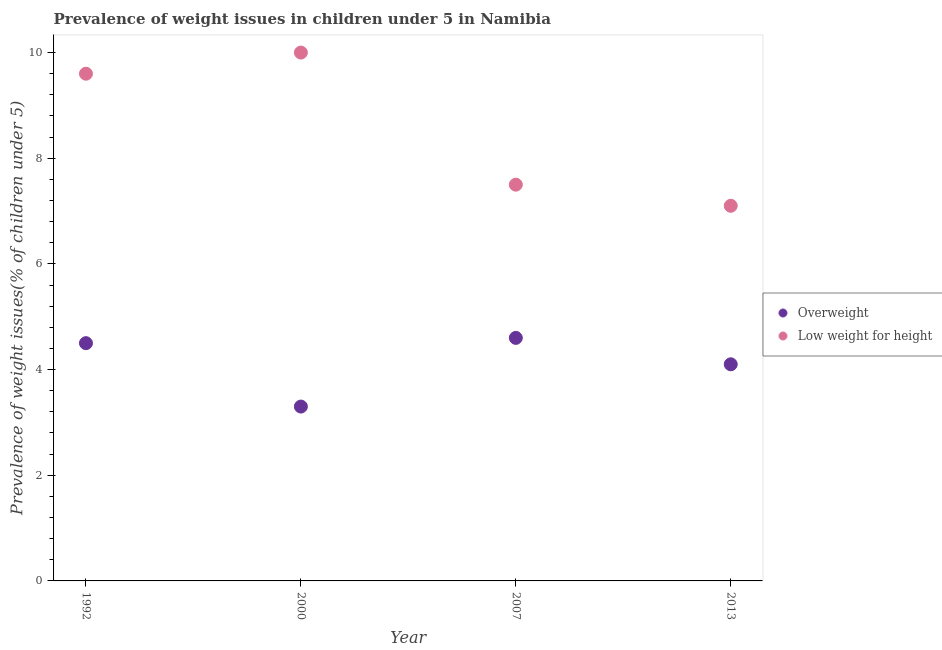How many different coloured dotlines are there?
Keep it short and to the point. 2. Is the number of dotlines equal to the number of legend labels?
Your answer should be very brief. Yes. What is the percentage of underweight children in 2007?
Your answer should be compact. 7.5. Across all years, what is the maximum percentage of overweight children?
Offer a terse response. 4.6. Across all years, what is the minimum percentage of underweight children?
Provide a succinct answer. 7.1. In which year was the percentage of underweight children minimum?
Ensure brevity in your answer.  2013. What is the total percentage of underweight children in the graph?
Ensure brevity in your answer.  34.2. What is the difference between the percentage of overweight children in 2007 and that in 2013?
Offer a terse response. 0.5. What is the difference between the percentage of underweight children in 2013 and the percentage of overweight children in 1992?
Give a very brief answer. 2.6. What is the average percentage of underweight children per year?
Offer a terse response. 8.55. In the year 2013, what is the difference between the percentage of overweight children and percentage of underweight children?
Your response must be concise. -3. In how many years, is the percentage of underweight children greater than 3.6 %?
Ensure brevity in your answer.  4. What is the ratio of the percentage of overweight children in 1992 to that in 2000?
Provide a short and direct response. 1.36. Is the percentage of underweight children in 1992 less than that in 2013?
Make the answer very short. No. What is the difference between the highest and the second highest percentage of overweight children?
Offer a terse response. 0.1. What is the difference between the highest and the lowest percentage of overweight children?
Provide a succinct answer. 1.3. Is the percentage of underweight children strictly greater than the percentage of overweight children over the years?
Keep it short and to the point. Yes. Is the percentage of underweight children strictly less than the percentage of overweight children over the years?
Offer a very short reply. No. How many dotlines are there?
Your response must be concise. 2. How many years are there in the graph?
Give a very brief answer. 4. Are the values on the major ticks of Y-axis written in scientific E-notation?
Ensure brevity in your answer.  No. Does the graph contain any zero values?
Make the answer very short. No. Where does the legend appear in the graph?
Ensure brevity in your answer.  Center right. What is the title of the graph?
Your answer should be very brief. Prevalence of weight issues in children under 5 in Namibia. What is the label or title of the Y-axis?
Offer a very short reply. Prevalence of weight issues(% of children under 5). What is the Prevalence of weight issues(% of children under 5) of Low weight for height in 1992?
Offer a very short reply. 9.6. What is the Prevalence of weight issues(% of children under 5) in Overweight in 2000?
Offer a terse response. 3.3. What is the Prevalence of weight issues(% of children under 5) of Overweight in 2007?
Your response must be concise. 4.6. What is the Prevalence of weight issues(% of children under 5) of Overweight in 2013?
Provide a succinct answer. 4.1. What is the Prevalence of weight issues(% of children under 5) of Low weight for height in 2013?
Your answer should be very brief. 7.1. Across all years, what is the maximum Prevalence of weight issues(% of children under 5) of Overweight?
Offer a terse response. 4.6. Across all years, what is the maximum Prevalence of weight issues(% of children under 5) of Low weight for height?
Offer a terse response. 10. Across all years, what is the minimum Prevalence of weight issues(% of children under 5) of Overweight?
Your response must be concise. 3.3. Across all years, what is the minimum Prevalence of weight issues(% of children under 5) in Low weight for height?
Give a very brief answer. 7.1. What is the total Prevalence of weight issues(% of children under 5) of Overweight in the graph?
Make the answer very short. 16.5. What is the total Prevalence of weight issues(% of children under 5) of Low weight for height in the graph?
Offer a very short reply. 34.2. What is the difference between the Prevalence of weight issues(% of children under 5) in Overweight in 1992 and that in 2000?
Provide a short and direct response. 1.2. What is the difference between the Prevalence of weight issues(% of children under 5) in Low weight for height in 1992 and that in 2007?
Your response must be concise. 2.1. What is the difference between the Prevalence of weight issues(% of children under 5) in Overweight in 1992 and that in 2013?
Provide a short and direct response. 0.4. What is the difference between the Prevalence of weight issues(% of children under 5) of Low weight for height in 1992 and that in 2013?
Provide a short and direct response. 2.5. What is the difference between the Prevalence of weight issues(% of children under 5) of Low weight for height in 2000 and that in 2007?
Your answer should be compact. 2.5. What is the difference between the Prevalence of weight issues(% of children under 5) of Overweight in 2000 and that in 2013?
Offer a very short reply. -0.8. What is the difference between the Prevalence of weight issues(% of children under 5) of Low weight for height in 2000 and that in 2013?
Ensure brevity in your answer.  2.9. What is the difference between the Prevalence of weight issues(% of children under 5) of Overweight in 1992 and the Prevalence of weight issues(% of children under 5) of Low weight for height in 2013?
Provide a succinct answer. -2.6. What is the difference between the Prevalence of weight issues(% of children under 5) of Overweight in 2000 and the Prevalence of weight issues(% of children under 5) of Low weight for height in 2013?
Offer a terse response. -3.8. What is the average Prevalence of weight issues(% of children under 5) of Overweight per year?
Offer a very short reply. 4.12. What is the average Prevalence of weight issues(% of children under 5) in Low weight for height per year?
Offer a terse response. 8.55. In the year 1992, what is the difference between the Prevalence of weight issues(% of children under 5) of Overweight and Prevalence of weight issues(% of children under 5) of Low weight for height?
Your answer should be very brief. -5.1. In the year 2000, what is the difference between the Prevalence of weight issues(% of children under 5) in Overweight and Prevalence of weight issues(% of children under 5) in Low weight for height?
Give a very brief answer. -6.7. In the year 2007, what is the difference between the Prevalence of weight issues(% of children under 5) of Overweight and Prevalence of weight issues(% of children under 5) of Low weight for height?
Offer a terse response. -2.9. What is the ratio of the Prevalence of weight issues(% of children under 5) of Overweight in 1992 to that in 2000?
Your response must be concise. 1.36. What is the ratio of the Prevalence of weight issues(% of children under 5) in Overweight in 1992 to that in 2007?
Make the answer very short. 0.98. What is the ratio of the Prevalence of weight issues(% of children under 5) of Low weight for height in 1992 to that in 2007?
Offer a very short reply. 1.28. What is the ratio of the Prevalence of weight issues(% of children under 5) of Overweight in 1992 to that in 2013?
Your answer should be compact. 1.1. What is the ratio of the Prevalence of weight issues(% of children under 5) in Low weight for height in 1992 to that in 2013?
Give a very brief answer. 1.35. What is the ratio of the Prevalence of weight issues(% of children under 5) in Overweight in 2000 to that in 2007?
Offer a terse response. 0.72. What is the ratio of the Prevalence of weight issues(% of children under 5) in Low weight for height in 2000 to that in 2007?
Provide a succinct answer. 1.33. What is the ratio of the Prevalence of weight issues(% of children under 5) in Overweight in 2000 to that in 2013?
Your answer should be compact. 0.8. What is the ratio of the Prevalence of weight issues(% of children under 5) in Low weight for height in 2000 to that in 2013?
Provide a short and direct response. 1.41. What is the ratio of the Prevalence of weight issues(% of children under 5) of Overweight in 2007 to that in 2013?
Ensure brevity in your answer.  1.12. What is the ratio of the Prevalence of weight issues(% of children under 5) in Low weight for height in 2007 to that in 2013?
Make the answer very short. 1.06. What is the difference between the highest and the second highest Prevalence of weight issues(% of children under 5) in Overweight?
Your response must be concise. 0.1. What is the difference between the highest and the second highest Prevalence of weight issues(% of children under 5) in Low weight for height?
Your response must be concise. 0.4. 